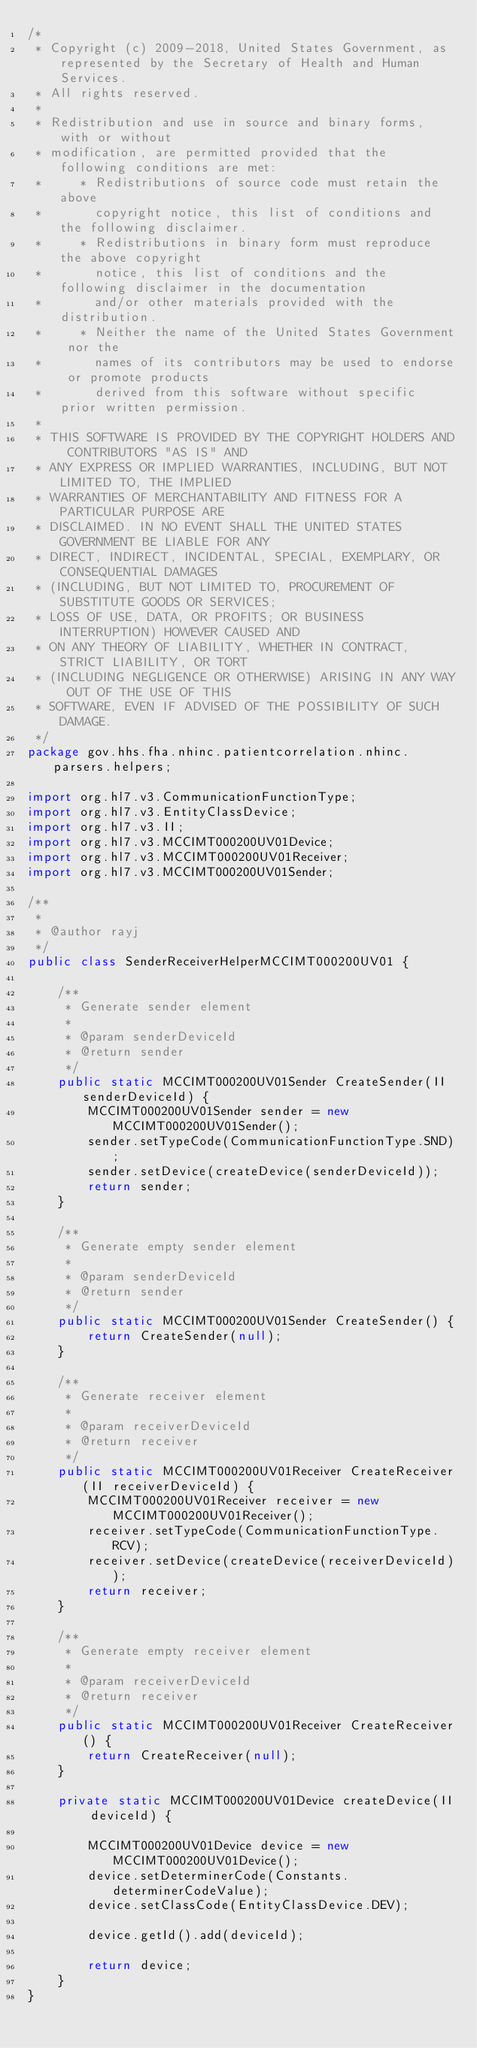<code> <loc_0><loc_0><loc_500><loc_500><_Java_>/*
 * Copyright (c) 2009-2018, United States Government, as represented by the Secretary of Health and Human Services.
 * All rights reserved.
 * 
 * Redistribution and use in source and binary forms, with or without
 * modification, are permitted provided that the following conditions are met:
 *     * Redistributions of source code must retain the above
 *       copyright notice, this list of conditions and the following disclaimer.
 *     * Redistributions in binary form must reproduce the above copyright
 *       notice, this list of conditions and the following disclaimer in the documentation
 *       and/or other materials provided with the distribution.
 *     * Neither the name of the United States Government nor the
 *       names of its contributors may be used to endorse or promote products
 *       derived from this software without specific prior written permission.
 * 
 * THIS SOFTWARE IS PROVIDED BY THE COPYRIGHT HOLDERS AND CONTRIBUTORS "AS IS" AND
 * ANY EXPRESS OR IMPLIED WARRANTIES, INCLUDING, BUT NOT LIMITED TO, THE IMPLIED
 * WARRANTIES OF MERCHANTABILITY AND FITNESS FOR A PARTICULAR PURPOSE ARE
 * DISCLAIMED. IN NO EVENT SHALL THE UNITED STATES GOVERNMENT BE LIABLE FOR ANY
 * DIRECT, INDIRECT, INCIDENTAL, SPECIAL, EXEMPLARY, OR CONSEQUENTIAL DAMAGES
 * (INCLUDING, BUT NOT LIMITED TO, PROCUREMENT OF SUBSTITUTE GOODS OR SERVICES;
 * LOSS OF USE, DATA, OR PROFITS; OR BUSINESS INTERRUPTION) HOWEVER CAUSED AND
 * ON ANY THEORY OF LIABILITY, WHETHER IN CONTRACT, STRICT LIABILITY, OR TORT
 * (INCLUDING NEGLIGENCE OR OTHERWISE) ARISING IN ANY WAY OUT OF THE USE OF THIS
 * SOFTWARE, EVEN IF ADVISED OF THE POSSIBILITY OF SUCH DAMAGE.
 */
package gov.hhs.fha.nhinc.patientcorrelation.nhinc.parsers.helpers;

import org.hl7.v3.CommunicationFunctionType;
import org.hl7.v3.EntityClassDevice;
import org.hl7.v3.II;
import org.hl7.v3.MCCIMT000200UV01Device;
import org.hl7.v3.MCCIMT000200UV01Receiver;
import org.hl7.v3.MCCIMT000200UV01Sender;

/**
 *
 * @author rayj
 */
public class SenderReceiverHelperMCCIMT000200UV01 {

    /**
     * Generate sender element
     *
     * @param senderDeviceId
     * @return sender
     */
    public static MCCIMT000200UV01Sender CreateSender(II senderDeviceId) {
        MCCIMT000200UV01Sender sender = new MCCIMT000200UV01Sender();
        sender.setTypeCode(CommunicationFunctionType.SND);
        sender.setDevice(createDevice(senderDeviceId));
        return sender;
    }

    /**
     * Generate empty sender element
     *
     * @param senderDeviceId
     * @return sender
     */
    public static MCCIMT000200UV01Sender CreateSender() {
        return CreateSender(null);
    }

    /**
     * Generate receiver element
     *
     * @param receiverDeviceId
     * @return receiver
     */
    public static MCCIMT000200UV01Receiver CreateReceiver(II receiverDeviceId) {
        MCCIMT000200UV01Receiver receiver = new MCCIMT000200UV01Receiver();
        receiver.setTypeCode(CommunicationFunctionType.RCV);
        receiver.setDevice(createDevice(receiverDeviceId));
        return receiver;
    }

    /**
     * Generate empty receiver element
     *
     * @param receiverDeviceId
     * @return receiver
     */
    public static MCCIMT000200UV01Receiver CreateReceiver() {
        return CreateReceiver(null);
    }

    private static MCCIMT000200UV01Device createDevice(II deviceId) {

        MCCIMT000200UV01Device device = new MCCIMT000200UV01Device();
        device.setDeterminerCode(Constants.determinerCodeValue);
        device.setClassCode(EntityClassDevice.DEV);

        device.getId().add(deviceId);

        return device;
    }
}
</code> 